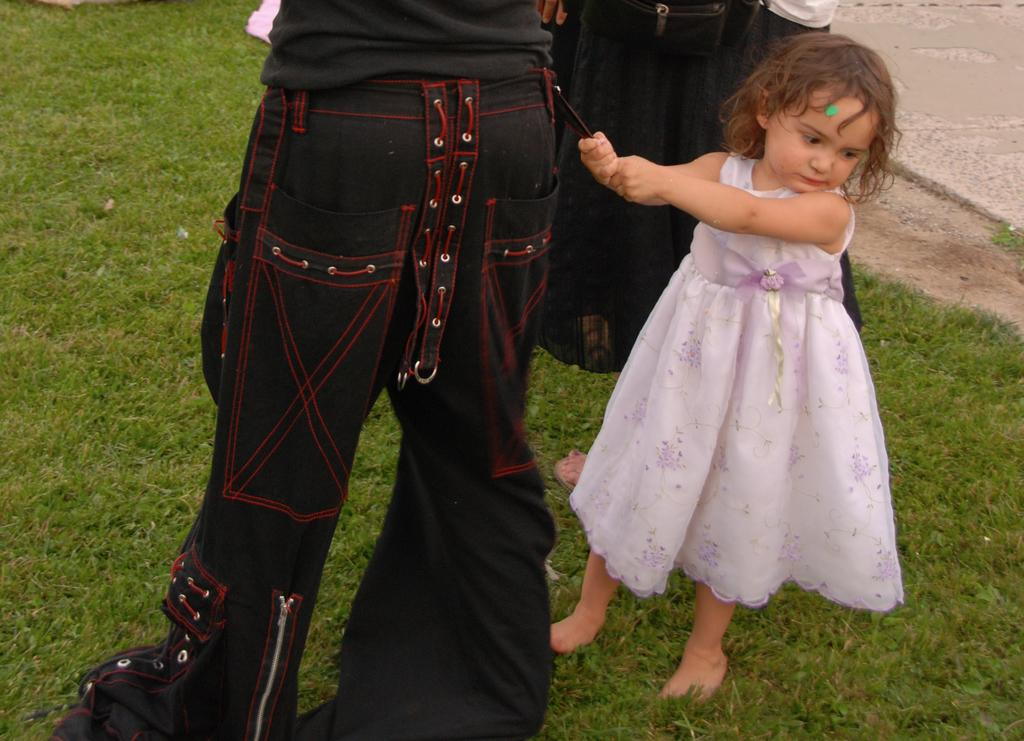Who is the main subject in the image? There is a girl in the image. What is the girl wearing? The girl is wearing a pink dress. How many other people are in the image? There are two other persons in the image. What are the other two people wearing? The two other persons are wearing black dresses. What is the setting of the image? All three individuals are standing on the grass. What type of gun can be seen in the image? There is no gun present in the image. Are there any apples visible in the image? There are no apples present in the image. 